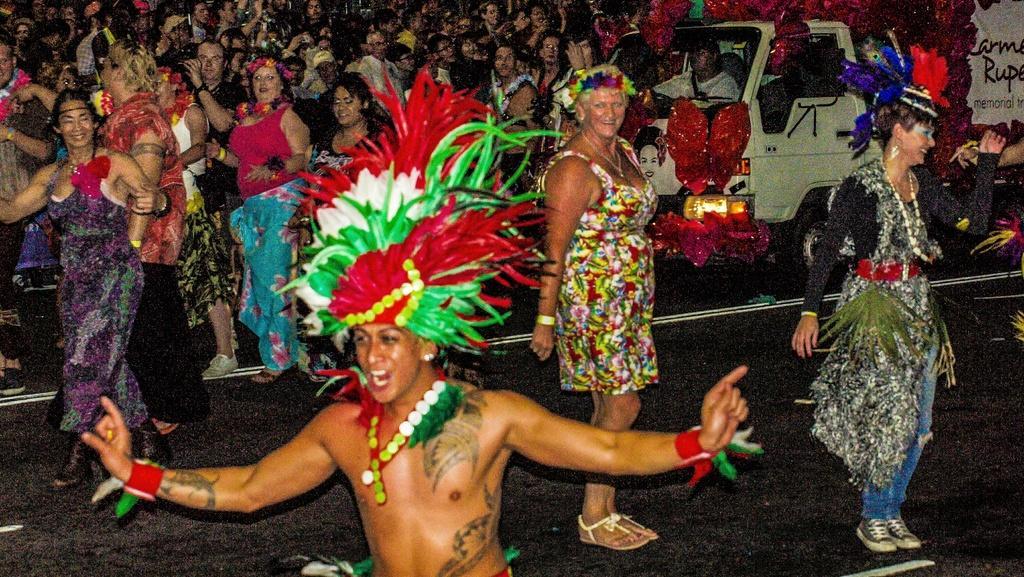Can you describe this image briefly? In this image we can see group of persons wearing costumes are standing on the ground. To the right side of the image we can see a person sitting inside a vehicle parked on the ground. 